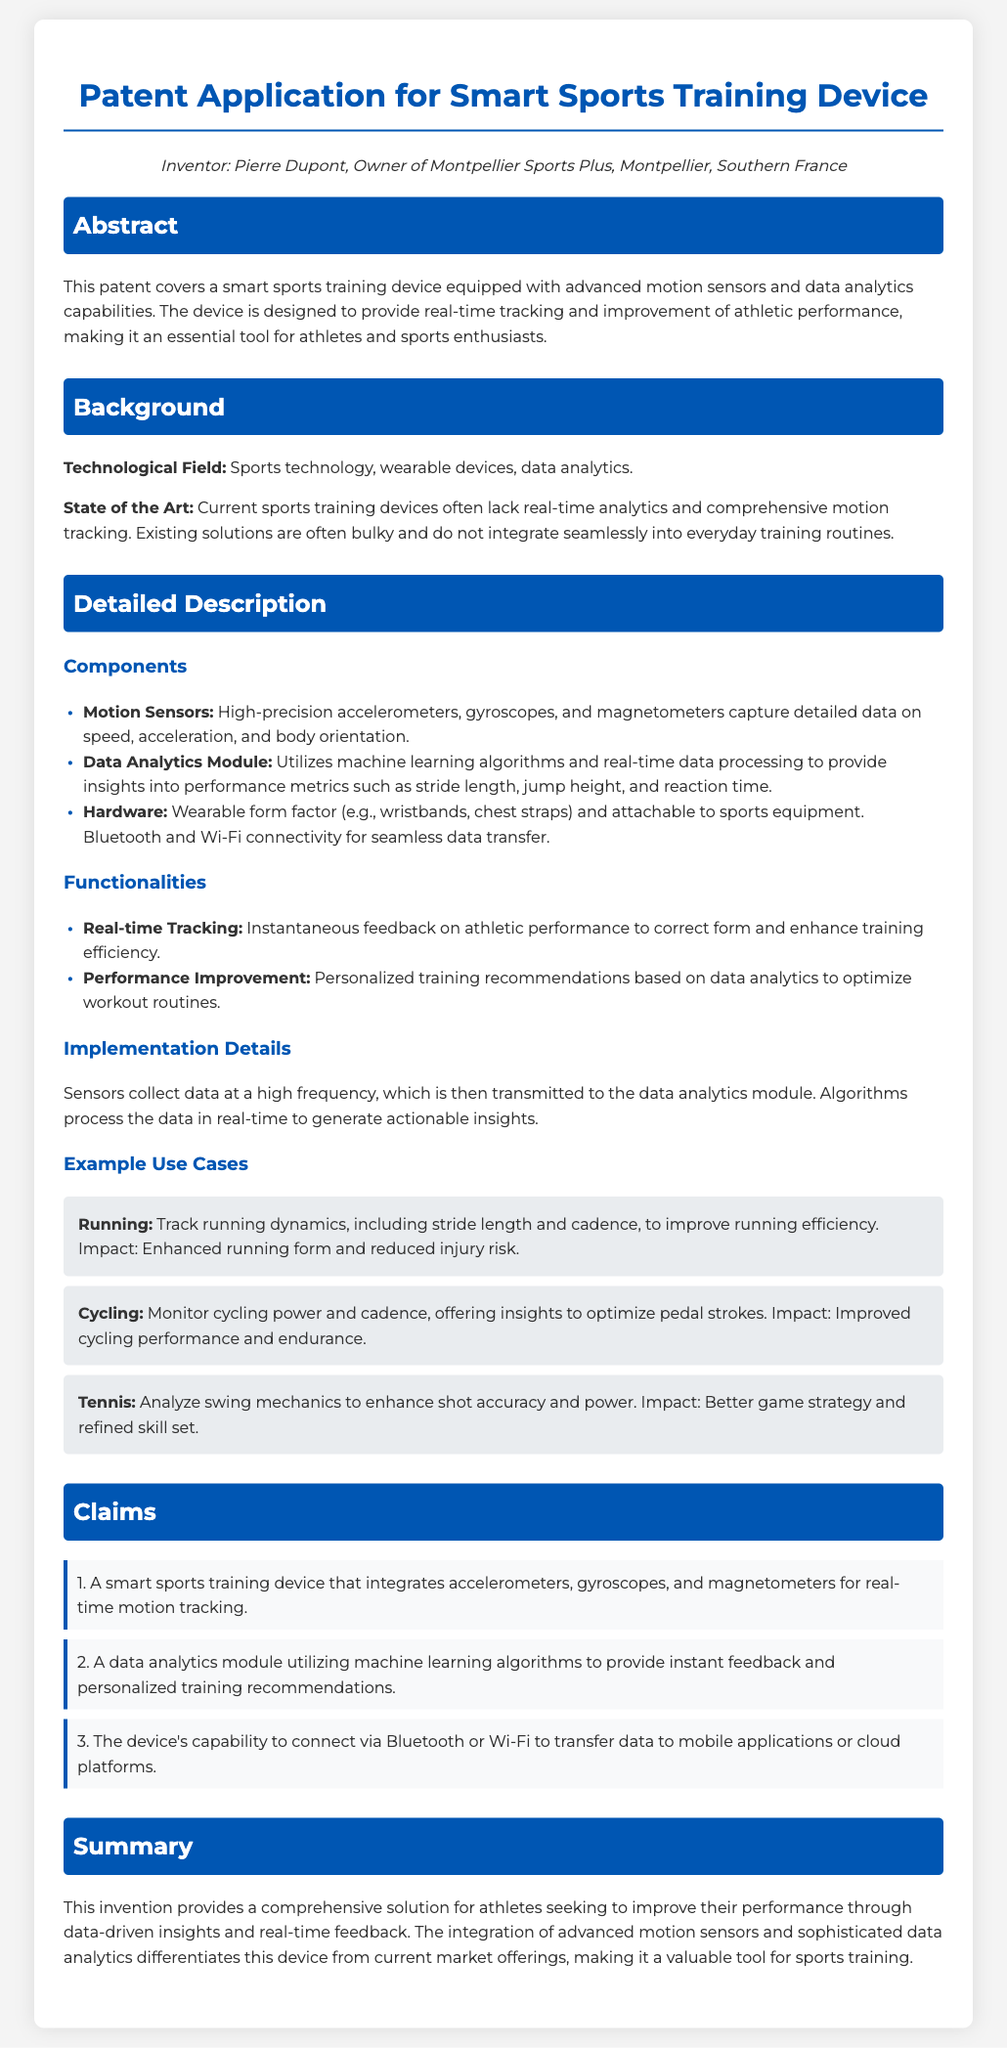What is the name of the inventor? The inventor is mentioned in the document, listed as "Pierre Dupont."
Answer: Pierre Dupont What is the main functionality of the device? The document states the main function as providing "real-time tracking" of athletic performance.
Answer: Real-time tracking What technology is used for data analysis? The document highlights the use of "machine learning algorithms" within the data analytics module.
Answer: Machine learning algorithms How many use cases are presented in the detailed description? The document outlines three specific use cases for the device in various sports activities.
Answer: Three What is one of the components used in the device? The detailed description lists "high-precision accelerometers" as one of the components.
Answer: High-precision accelerometers Who owns Montpellier Sports Plus? The document identifies Pierre Dupont as the owner of Montpellier Sports Plus.
Answer: Pierre Dupont What is the purpose of the data analytics module? The purpose is described as providing "instant feedback and personalized training recommendations."
Answer: Instant feedback and personalized training recommendations Which connectivity options does the device support? The claims mention connectivity options as "Bluetooth or Wi-Fi."
Answer: Bluetooth or Wi-Fi What is claimed in the first patent claim? The first claim specifies the integration of sensors for "real-time motion tracking."
Answer: Real-time motion tracking 